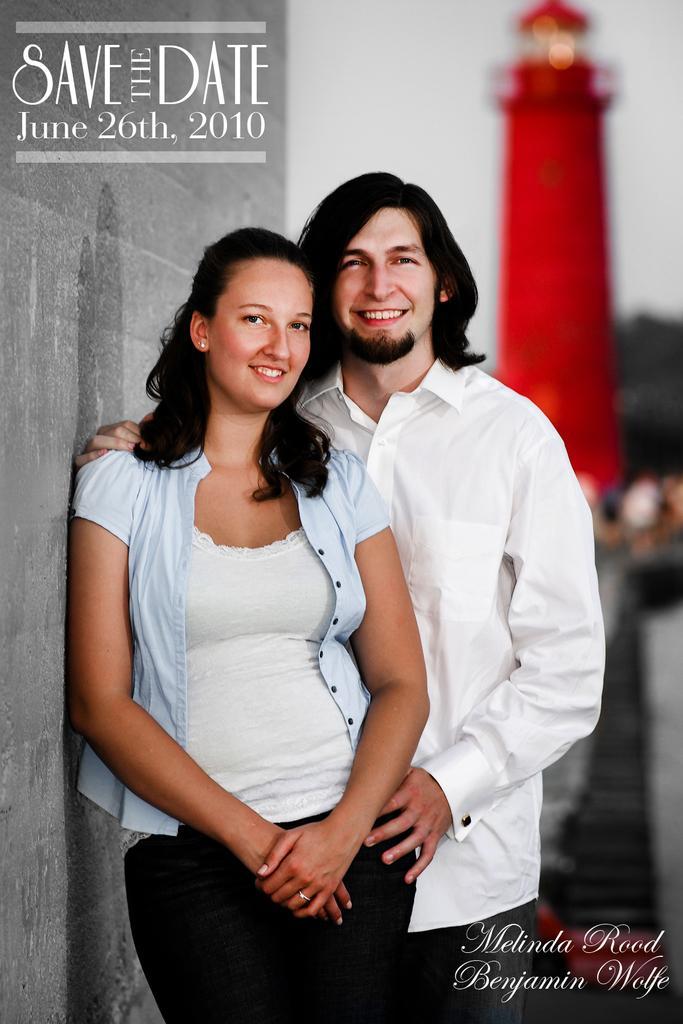Can you describe this image briefly? In this image in the foreground there are two persons who are standing and smiling, and on the left side there is a wall. And in the background there is one tower and some trees, and at the top and bottom of the image there is some text. 